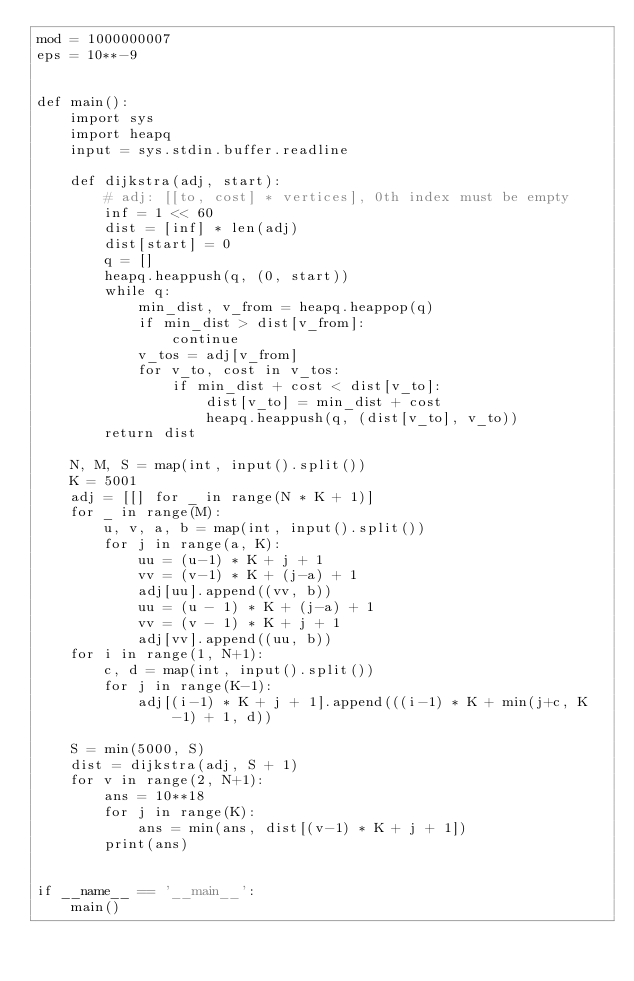<code> <loc_0><loc_0><loc_500><loc_500><_Python_>mod = 1000000007
eps = 10**-9


def main():
    import sys
    import heapq
    input = sys.stdin.buffer.readline

    def dijkstra(adj, start):
        # adj: [[to, cost] * vertices], 0th index must be empty
        inf = 1 << 60
        dist = [inf] * len(adj)
        dist[start] = 0
        q = []
        heapq.heappush(q, (0, start))
        while q:
            min_dist, v_from = heapq.heappop(q)
            if min_dist > dist[v_from]:
                continue
            v_tos = adj[v_from]
            for v_to, cost in v_tos:
                if min_dist + cost < dist[v_to]:
                    dist[v_to] = min_dist + cost
                    heapq.heappush(q, (dist[v_to], v_to))
        return dist

    N, M, S = map(int, input().split())
    K = 5001
    adj = [[] for _ in range(N * K + 1)]
    for _ in range(M):
        u, v, a, b = map(int, input().split())
        for j in range(a, K):
            uu = (u-1) * K + j + 1
            vv = (v-1) * K + (j-a) + 1
            adj[uu].append((vv, b))
            uu = (u - 1) * K + (j-a) + 1
            vv = (v - 1) * K + j + 1
            adj[vv].append((uu, b))
    for i in range(1, N+1):
        c, d = map(int, input().split())
        for j in range(K-1):
            adj[(i-1) * K + j + 1].append(((i-1) * K + min(j+c, K-1) + 1, d))

    S = min(5000, S)
    dist = dijkstra(adj, S + 1)
    for v in range(2, N+1):
        ans = 10**18
        for j in range(K):
            ans = min(ans, dist[(v-1) * K + j + 1])
        print(ans)


if __name__ == '__main__':
    main()
</code> 